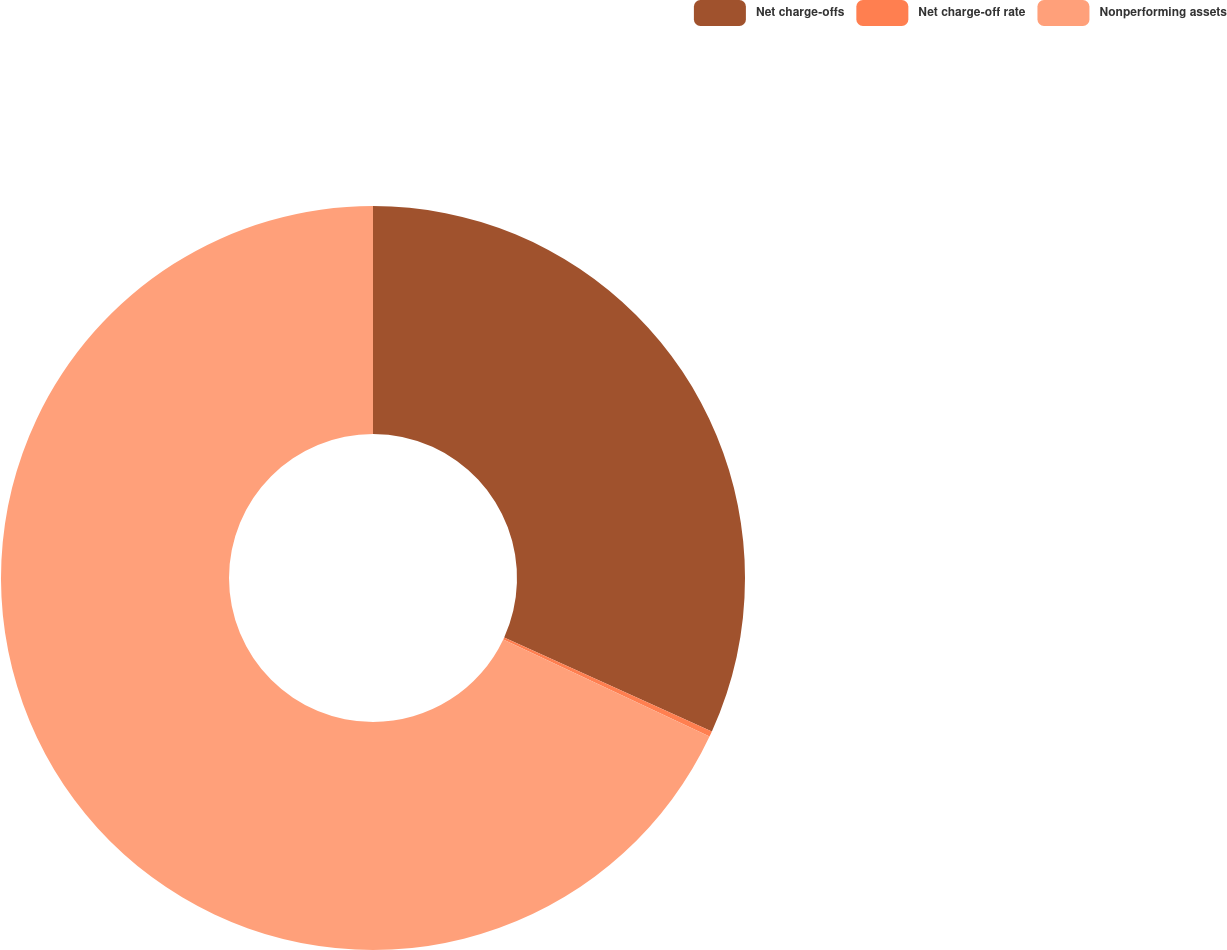Convert chart to OTSL. <chart><loc_0><loc_0><loc_500><loc_500><pie_chart><fcel>Net charge-offs<fcel>Net charge-off rate<fcel>Nonperforming assets<nl><fcel>31.77%<fcel>0.24%<fcel>67.99%<nl></chart> 